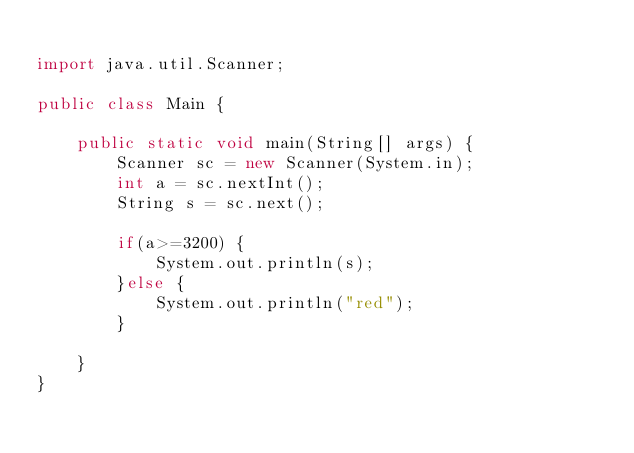Convert code to text. <code><loc_0><loc_0><loc_500><loc_500><_Java_>
import java.util.Scanner;

public class Main {

	public static void main(String[] args) {
		Scanner sc = new Scanner(System.in);
		int a = sc.nextInt();
		String s = sc.next();

		if(a>=3200) {
			System.out.println(s);
		}else {
			System.out.println("red");
		}

	}
}</code> 